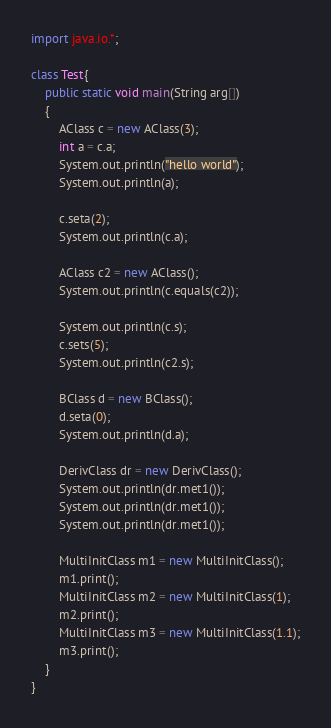<code> <loc_0><loc_0><loc_500><loc_500><_Java_>import java.io.*;

class Test{
    public static void main(String arg[])
    {
        AClass c = new AClass(3);
        int a = c.a;
        System.out.println("hello world");
        System.out.println(a);

        c.seta(2);
        System.out.println(c.a);

        AClass c2 = new AClass();
        System.out.println(c.equals(c2));

        System.out.println(c.s);
        c.sets(5);
        System.out.println(c2.s);

        BClass d = new BClass();
        d.seta(0);
        System.out.println(d.a);

        DerivClass dr = new DerivClass();
        System.out.println(dr.met1());
        System.out.println(dr.met1());
        System.out.println(dr.met1());

        MultiInitClass m1 = new MultiInitClass();
        m1.print();
        MultiInitClass m2 = new MultiInitClass(1);
        m2.print();
        MultiInitClass m3 = new MultiInitClass(1.1);
        m3.print();
    }
}
</code> 